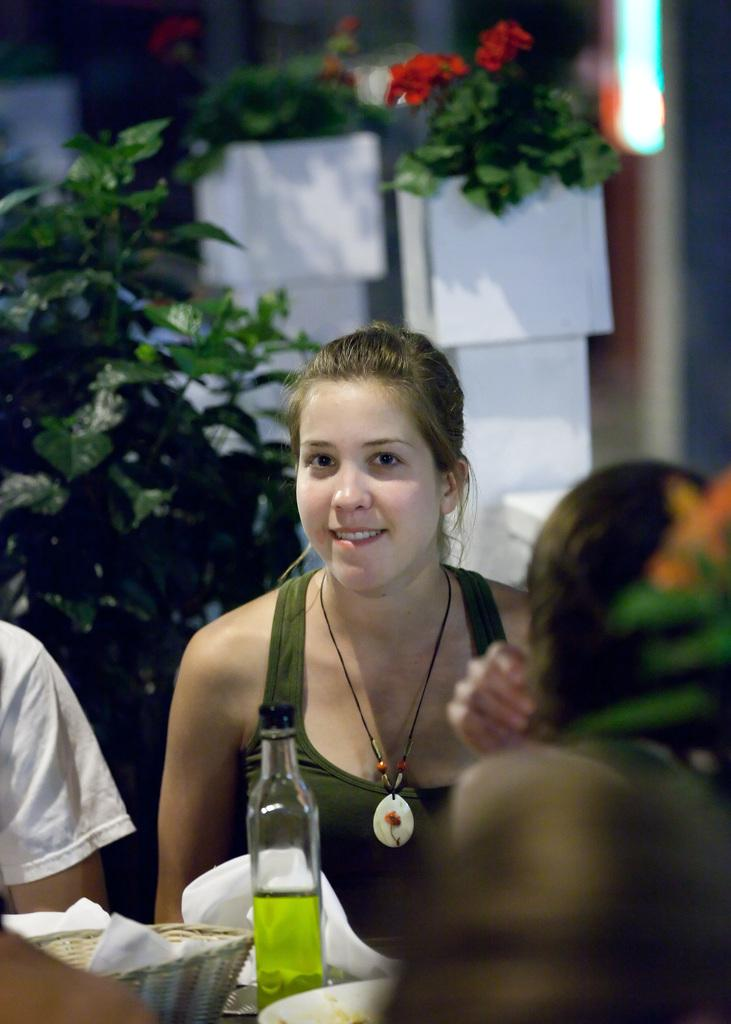Who is the main subject in the image? There is a lady in the image. What is the lady wearing? The lady is wearing a green t-shirt. What is the lady doing in the image? The lady is sitting. What objects can be seen on the table in the image? There is a bottle, a plate, and a basket on the table. What can be seen in the background of the image? There are plants in the background of the image. Can you tell me what color the lady's dad's mitten is in the image? There is no dad or mitten present in the image. What type of tooth is visible in the lady's mouth in the image? There is no tooth visible in the image; it is a lady sitting and wearing a green t-shirt. 